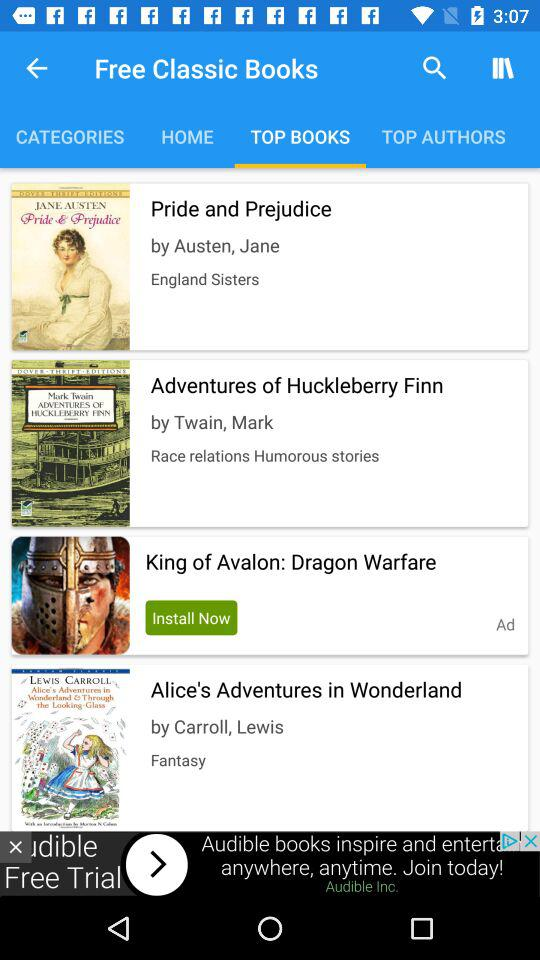Who is the writer of "Adventures of Huckleberry Finn"? The writer is Twain, Mark. 